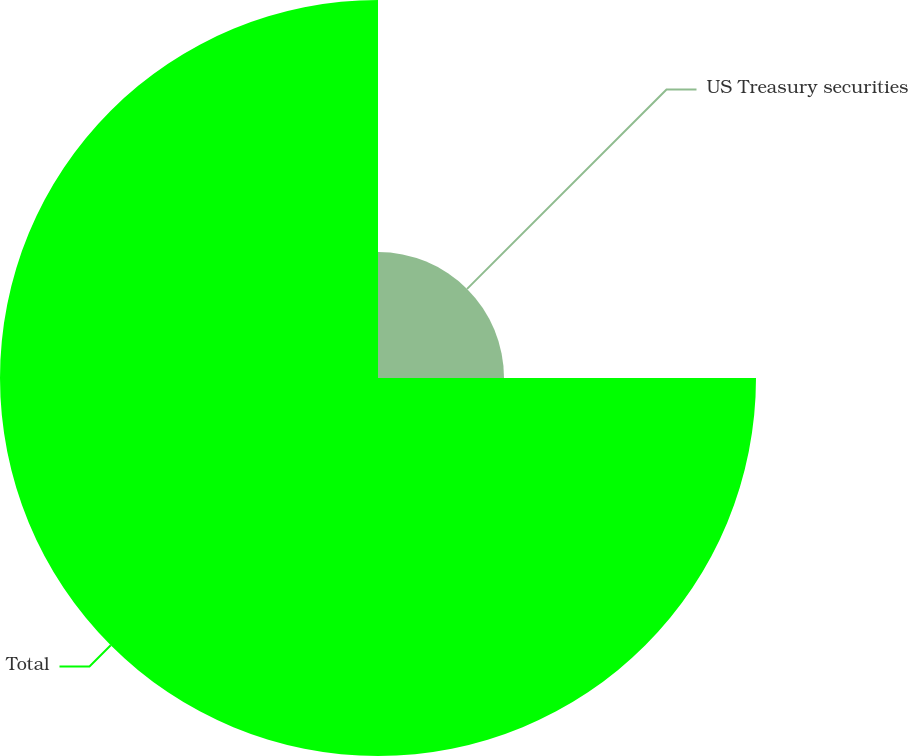<chart> <loc_0><loc_0><loc_500><loc_500><pie_chart><fcel>US Treasury securities<fcel>Total<nl><fcel>25.0%<fcel>75.0%<nl></chart> 